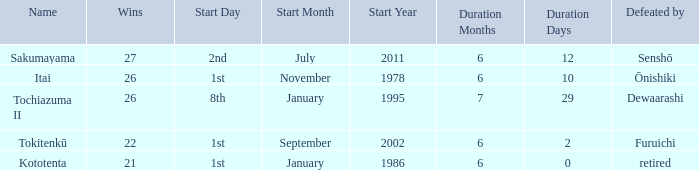Which Start has a Duration of 6 months 2 days? 1st day September 2002. Parse the table in full. {'header': ['Name', 'Wins', 'Start Day', 'Start Month', 'Start Year', 'Duration Months', 'Duration Days', 'Defeated by'], 'rows': [['Sakumayama', '27', '2nd', 'July', '2011', '6', '12', 'Senshō'], ['Itai', '26', '1st', 'November', '1978', '6', '10', 'Ōnishiki'], ['Tochiazuma II', '26', '8th', 'January', '1995', '7', '29', 'Dewaarashi'], ['Tokitenkū', '22', '1st', 'September', '2002', '6', '2', 'Furuichi'], ['Kototenta', '21', '1st', 'January', '1986', '6', '0', 'retired']]} 